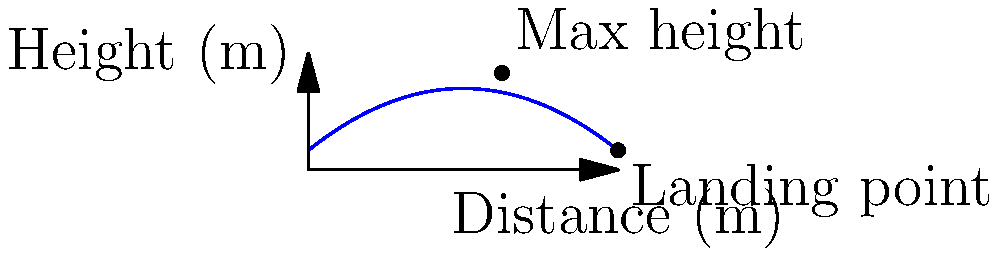Your former teammate Henry Rylah is practicing his kicking skills. He kicks a rugby ball, and its trajectory follows the parabolic path shown in the graph. The equation of the path is $h = -0.05d^2 + 0.8d + 1$, where $h$ is the height in meters and $d$ is the distance in meters. What is the total distance the ball travels before hitting the ground? To find the total distance the ball travels, we need to determine where the parabola intersects the x-axis (ground level). This occurs when the height (h) is zero.

1. Set up the equation:
   $0 = -0.05d^2 + 0.8d + 1$

2. Rearrange to standard quadratic form:
   $0.05d^2 - 0.8d - 1 = 0$

3. Use the quadratic formula: $d = \frac{-b \pm \sqrt{b^2 - 4ac}}{2a}$
   Where $a = 0.05$, $b = -0.8$, and $c = -1$

4. Substitute into the quadratic formula:
   $d = \frac{0.8 \pm \sqrt{(-0.8)^2 - 4(0.05)(-1)}}{2(0.05)}$

5. Simplify:
   $d = \frac{0.8 \pm \sqrt{0.64 + 0.2}}{0.1} = \frac{0.8 \pm \sqrt{0.84}}{0.1}$

6. Calculate:
   $d = \frac{0.8 \pm 0.9165}{0.1} = 8 \pm 9.165$

7. This gives us two solutions:
   $d_1 = 17.165$ and $d_2 = -1.165$

8. Since distance cannot be negative, we take the positive solution.

Therefore, the ball travels approximately 17.165 meters before hitting the ground.
Answer: 17.17 m 